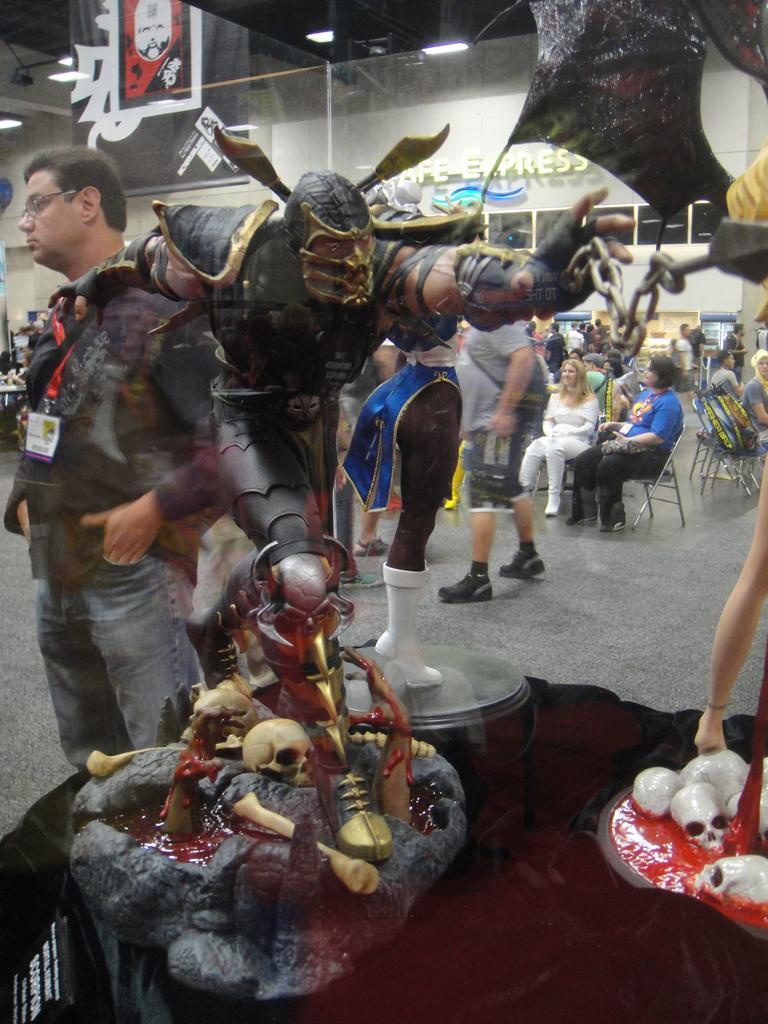Please provide a concise description of this image. In this image I can see group of people, some are sitting and some are standing. In front I can see few statues in multi color, background I can see few lights and few banners and the wall is in white color. 